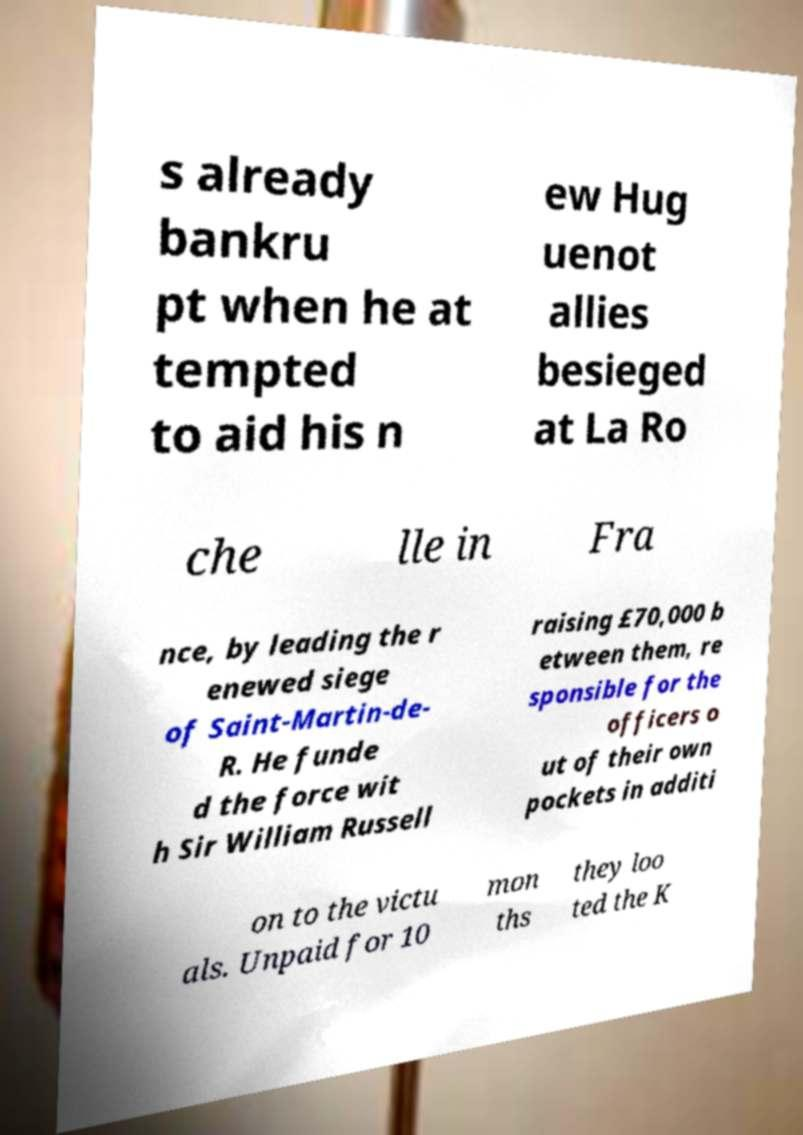There's text embedded in this image that I need extracted. Can you transcribe it verbatim? s already bankru pt when he at tempted to aid his n ew Hug uenot allies besieged at La Ro che lle in Fra nce, by leading the r enewed siege of Saint-Martin-de- R. He funde d the force wit h Sir William Russell raising £70,000 b etween them, re sponsible for the officers o ut of their own pockets in additi on to the victu als. Unpaid for 10 mon ths they loo ted the K 